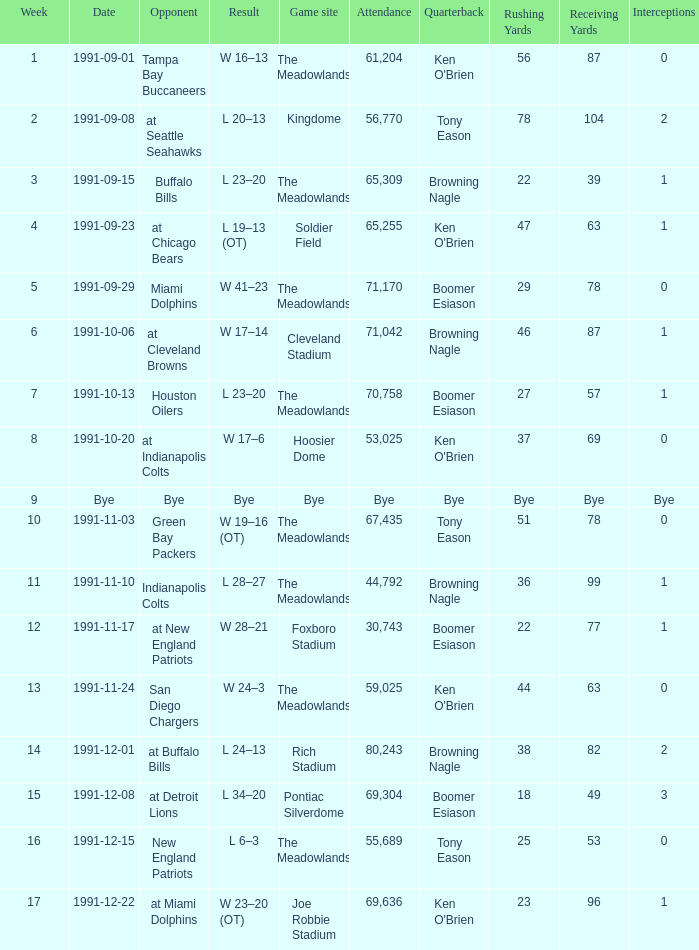What was the Attendance in Week 17? 69636.0. 